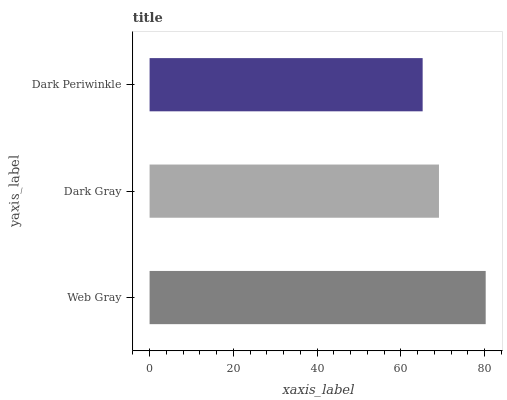Is Dark Periwinkle the minimum?
Answer yes or no. Yes. Is Web Gray the maximum?
Answer yes or no. Yes. Is Dark Gray the minimum?
Answer yes or no. No. Is Dark Gray the maximum?
Answer yes or no. No. Is Web Gray greater than Dark Gray?
Answer yes or no. Yes. Is Dark Gray less than Web Gray?
Answer yes or no. Yes. Is Dark Gray greater than Web Gray?
Answer yes or no. No. Is Web Gray less than Dark Gray?
Answer yes or no. No. Is Dark Gray the high median?
Answer yes or no. Yes. Is Dark Gray the low median?
Answer yes or no. Yes. Is Dark Periwinkle the high median?
Answer yes or no. No. Is Web Gray the low median?
Answer yes or no. No. 